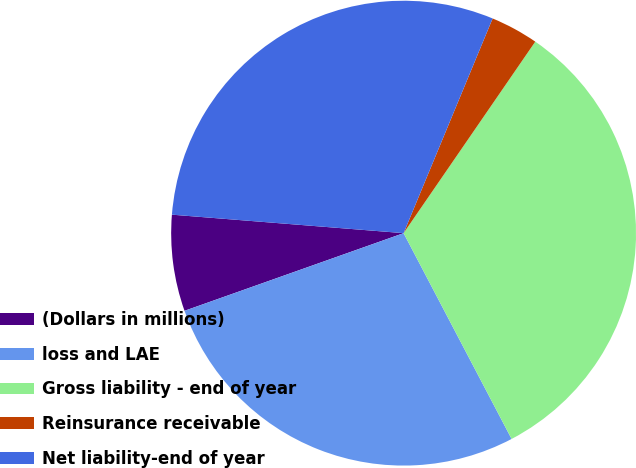Convert chart to OTSL. <chart><loc_0><loc_0><loc_500><loc_500><pie_chart><fcel>(Dollars in millions)<fcel>loss and LAE<fcel>Gross liability - end of year<fcel>Reinsurance receivable<fcel>Net liability-end of year<nl><fcel>6.69%<fcel>27.27%<fcel>32.72%<fcel>3.33%<fcel>29.99%<nl></chart> 